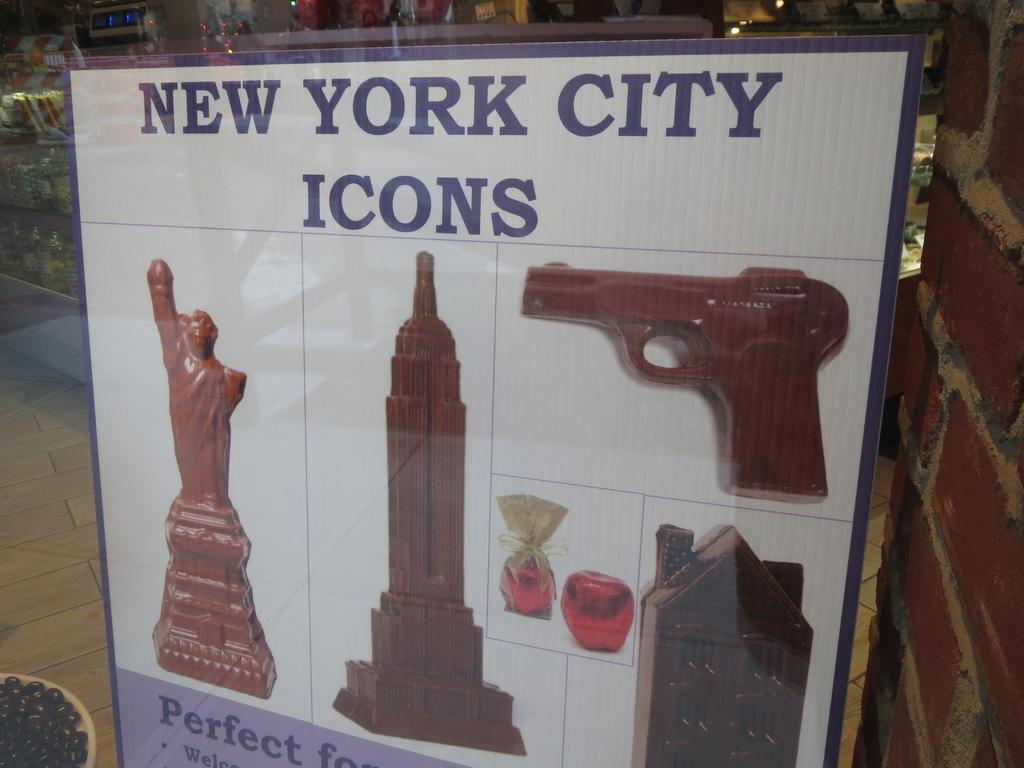What is the statue of liberty considered?
Provide a succinct answer. New york city icon. What city is featured on this sign?
Offer a terse response. New york city. 